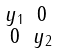<formula> <loc_0><loc_0><loc_500><loc_500>\begin{smallmatrix} y _ { 1 } & 0 \\ 0 & y _ { 2 } \end{smallmatrix}</formula> 